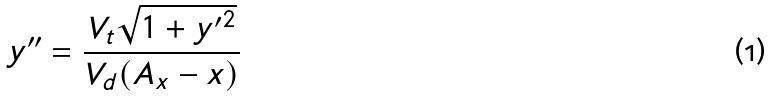<formula> <loc_0><loc_0><loc_500><loc_500>y ^ { \prime \prime } = \frac { V _ { t } \sqrt { 1 + { y ^ { \prime } } ^ { 2 } } } { V _ { d } ( A _ { x } - x ) }</formula> 